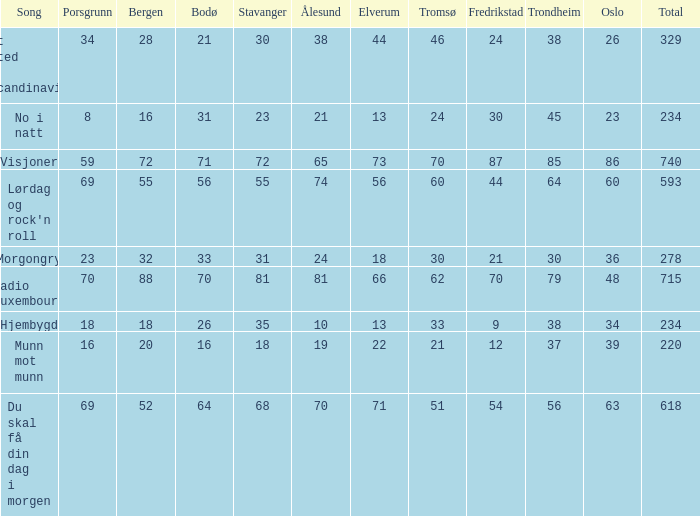When the total score is 740, what is tromso? 70.0. 